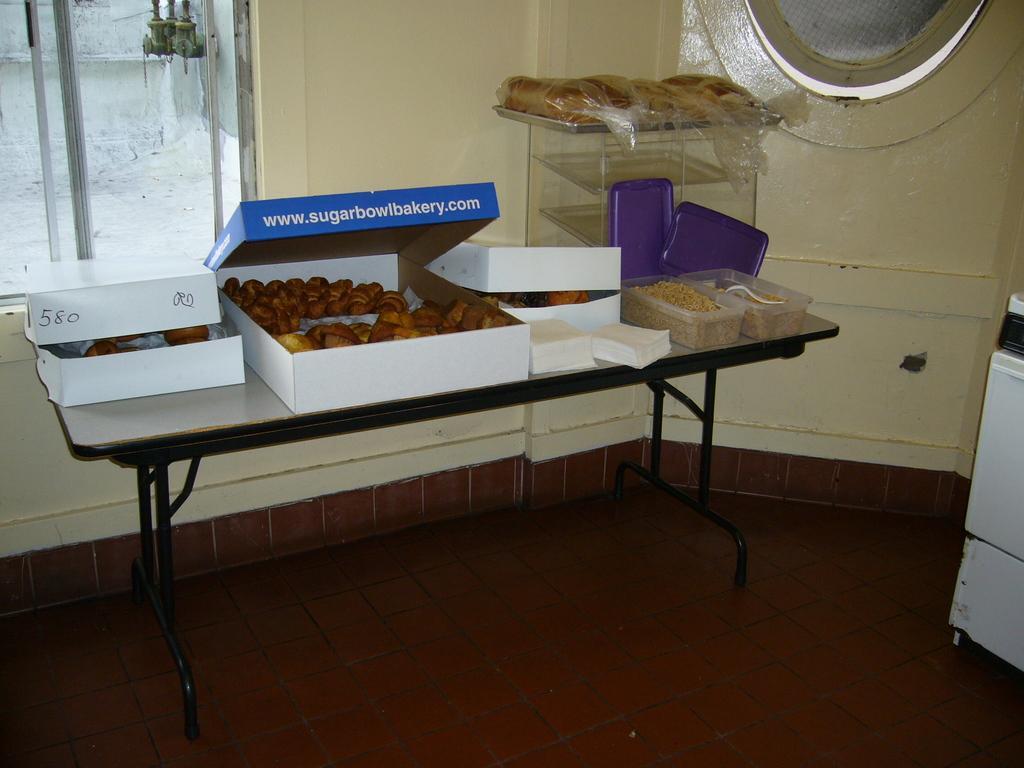Could you give a brief overview of what you see in this image? In the center of the image there is a table on which there are food items. In the background of the image there is a window. There is a wall. In the bottom of the image there is flooring. 